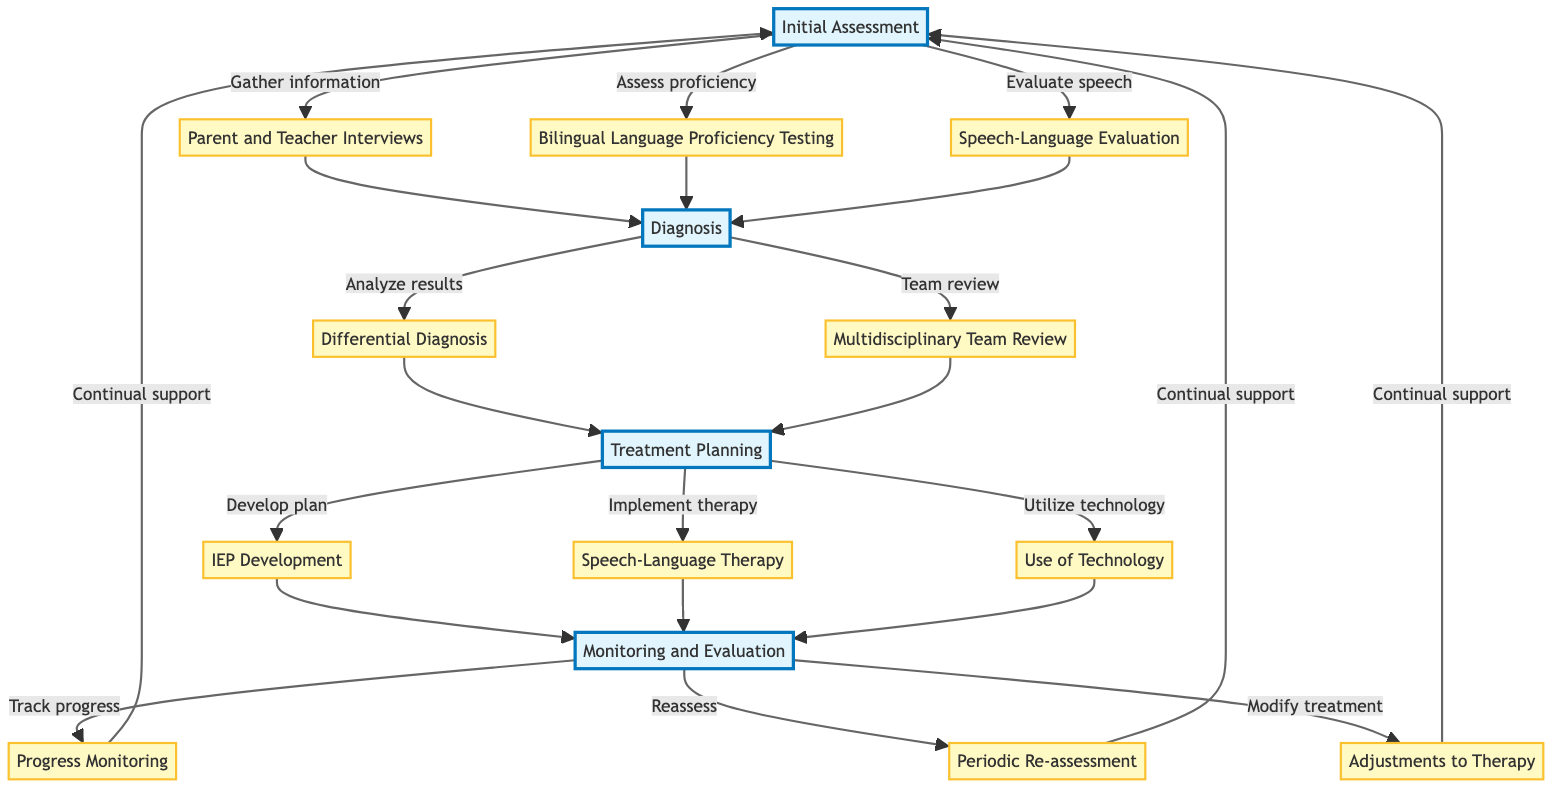What is the first step in the clinical pathway? The initial step in the clinical pathway is labeled "Parent and Teacher Interviews," which is the first node under the "Initial Assessment" section.
Answer: Parent and Teacher Interviews How many steps are there in the Diagnosis section? The Diagnosis section contains two distinct steps, which are "Differential Diagnosis" and "Multidisciplinary Team Review."
Answer: 2 What tools are used in the Speech-Language Evaluation step? The tools listed for the Speech-Language Evaluation step include "Clinical Evaluation of Language Fundamentals" and "Bilingual Aphasia Test."
Answer: Clinical Evaluation of Language Fundamentals, Bilingual Aphasia Test What follows the "Speech-Language Therapy" step? After the "Speech-Language Therapy" step, the next step in the pathway is "Monitoring and Evaluation." This indicates a progression toward assessing the treatment's effectiveness.
Answer: Monitoring and Evaluation Which professionals are involved in the Multidisciplinary Team Review? The professionals involved in the Multidisciplinary Team Review are a "Speech-Language Pathologist," a "Psychologist," and an "Educational Therapist."
Answer: Speech-Language Pathologist, Psychologist, Educational Therapist What step involves adjusting therapy based on progress? The step that involves modifying treatment plans based on the child's progress is called "Adjustments to Therapy." This step is crucial for responsive therapy management.
Answer: Adjustments to Therapy What is the ultimate goal of the clinical pathway? The ultimate goal of the clinical pathway is "Continual support," which signifies ongoing assistance and adaptation of therapy methods.
Answer: Continual support How is progress monitored according to the pathway? Progress is monitored through "Progress Monitoring," which includes regular assessments and feedback from parents and teachers to track improvements.
Answer: Progress Monitoring What is the relationship between Initial Assessment and Diagnosis? The relationship indicates that after completing the "Initial Assessment," the process proceeds to the "Diagnosis" section, which builds upon the data collected in the assessment phase.
Answer: Initial Assessment leads to Diagnosis 